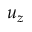Convert formula to latex. <formula><loc_0><loc_0><loc_500><loc_500>u _ { z }</formula> 